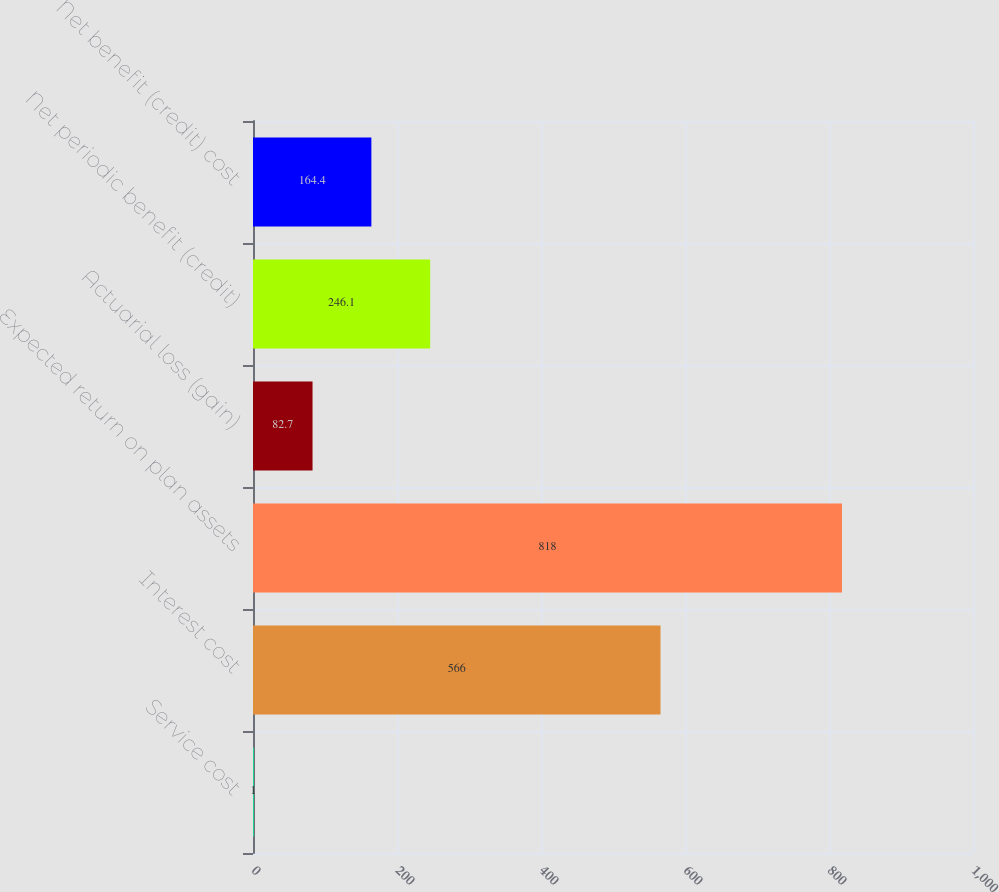<chart> <loc_0><loc_0><loc_500><loc_500><bar_chart><fcel>Service cost<fcel>Interest cost<fcel>Expected return on plan assets<fcel>Actuarial loss (gain)<fcel>Net periodic benefit (credit)<fcel>Net benefit (credit) cost<nl><fcel>1<fcel>566<fcel>818<fcel>82.7<fcel>246.1<fcel>164.4<nl></chart> 